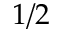Convert formula to latex. <formula><loc_0><loc_0><loc_500><loc_500>1 / 2</formula> 